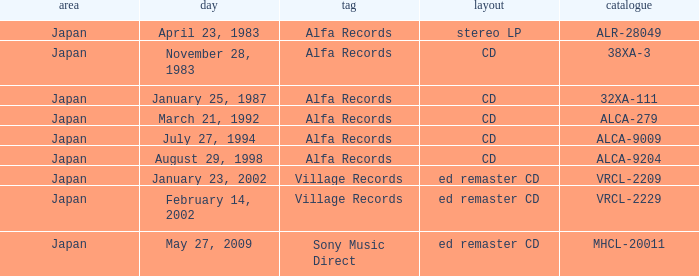Which region is identified as 38xa-3 in the catalog? Japan. 